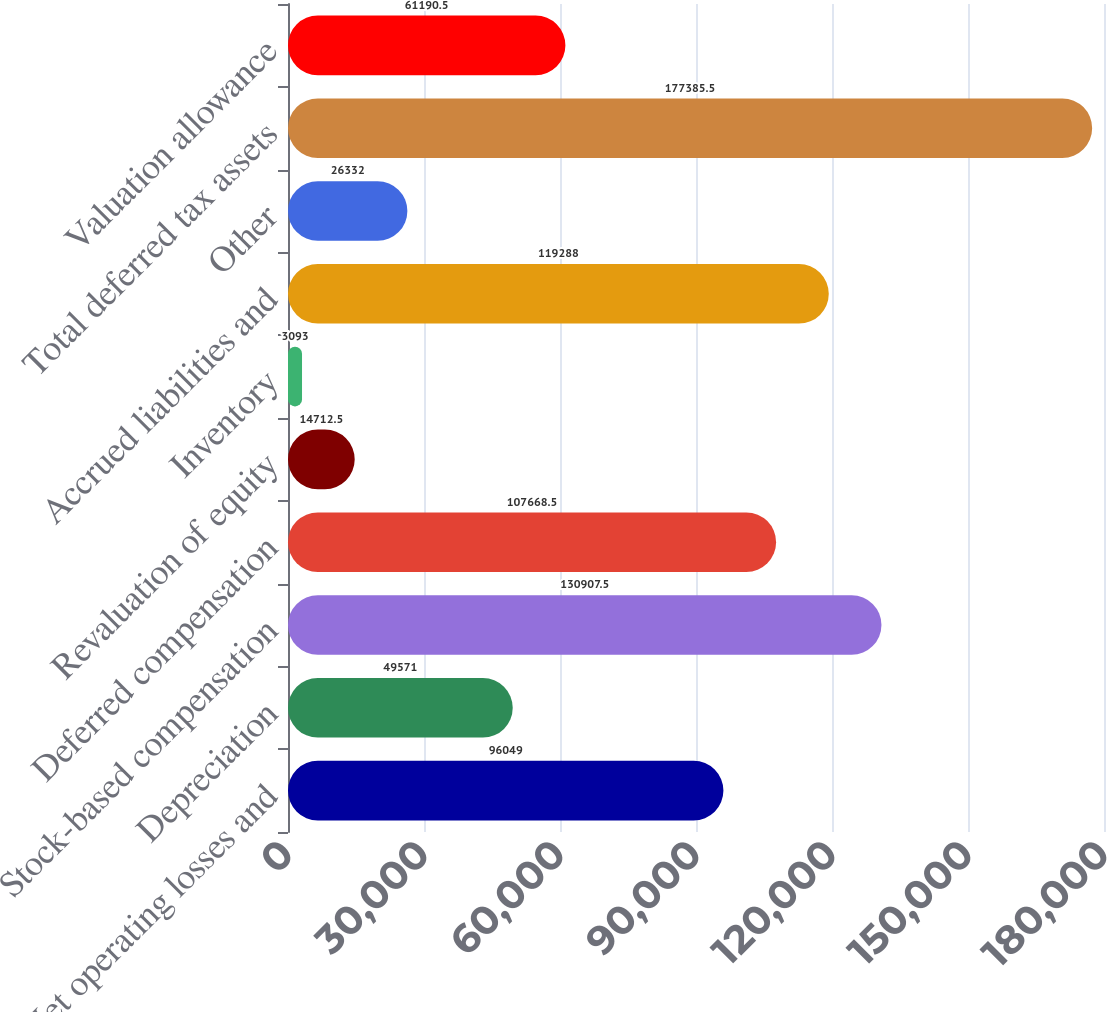<chart> <loc_0><loc_0><loc_500><loc_500><bar_chart><fcel>Net operating losses and<fcel>Depreciation<fcel>Stock-based compensation<fcel>Deferred compensation<fcel>Revaluation of equity<fcel>Inventory<fcel>Accrued liabilities and<fcel>Other<fcel>Total deferred tax assets<fcel>Valuation allowance<nl><fcel>96049<fcel>49571<fcel>130908<fcel>107668<fcel>14712.5<fcel>3093<fcel>119288<fcel>26332<fcel>177386<fcel>61190.5<nl></chart> 